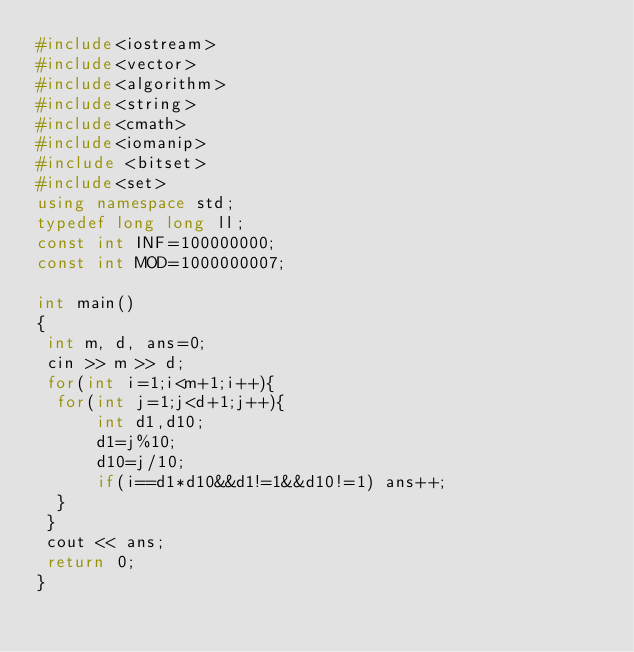<code> <loc_0><loc_0><loc_500><loc_500><_C++_>#include<iostream>
#include<vector>
#include<algorithm>
#include<string>
#include<cmath>
#include<iomanip>
#include <bitset>
#include<set>
using namespace std;
typedef long long ll;
const int INF=100000000;
const int MOD=1000000007;
 
int main()
{
 int m, d, ans=0;
 cin >> m >> d;
 for(int i=1;i<m+1;i++){
 	for(int j=1;j<d+1;j++){
   		int d1,d10;
   		d1=j%10;
   		d10=j/10;
   		if(i==d1*d10&&d1!=1&&d10!=1) ans++;
 	}
 }
 cout << ans;
 return 0;
}</code> 